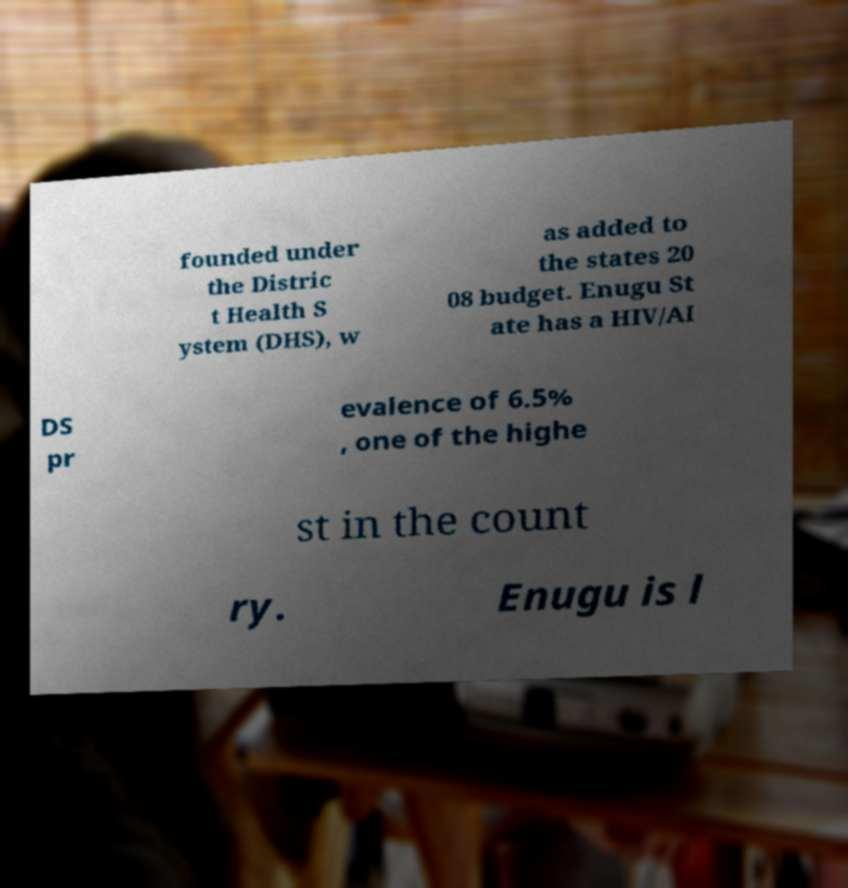What messages or text are displayed in this image? I need them in a readable, typed format. founded under the Distric t Health S ystem (DHS), w as added to the states 20 08 budget. Enugu St ate has a HIV/AI DS pr evalence of 6.5% , one of the highe st in the count ry. Enugu is l 